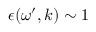<formula> <loc_0><loc_0><loc_500><loc_500>\epsilon ( \omega ^ { \prime } , k ) \sim 1</formula> 